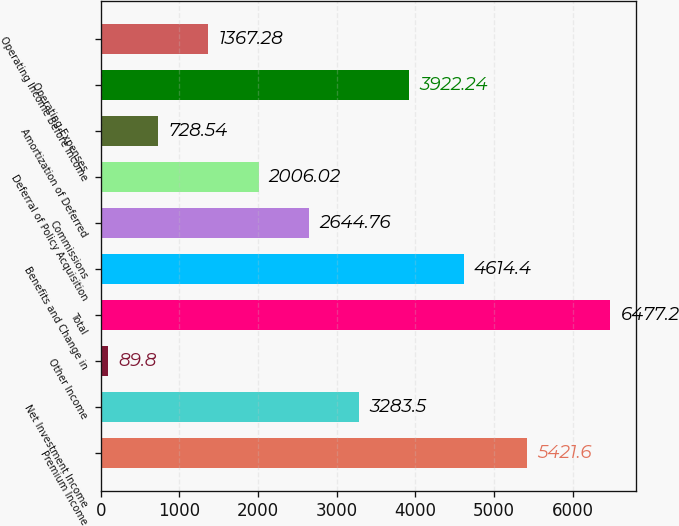Convert chart. <chart><loc_0><loc_0><loc_500><loc_500><bar_chart><fcel>Premium Income<fcel>Net Investment Income<fcel>Other Income<fcel>Total<fcel>Benefits and Change in<fcel>Commissions<fcel>Deferral of Policy Acquisition<fcel>Amortization of Deferred<fcel>Operating Expenses<fcel>Operating Income Before Income<nl><fcel>5421.6<fcel>3283.5<fcel>89.8<fcel>6477.2<fcel>4614.4<fcel>2644.76<fcel>2006.02<fcel>728.54<fcel>3922.24<fcel>1367.28<nl></chart> 